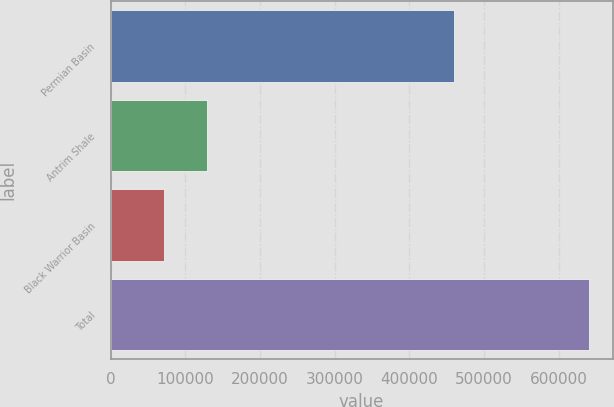<chart> <loc_0><loc_0><loc_500><loc_500><bar_chart><fcel>Permian Basin<fcel>Antrim Shale<fcel>Black Warrior Basin<fcel>Total<nl><fcel>459577<fcel>128871<fcel>72064<fcel>640131<nl></chart> 